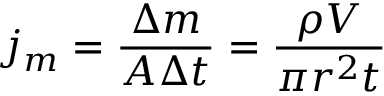Convert formula to latex. <formula><loc_0><loc_0><loc_500><loc_500>j _ { m } = { \frac { \Delta m } { A \Delta t } } = { \frac { \rho V } { \pi r ^ { 2 } t } }</formula> 